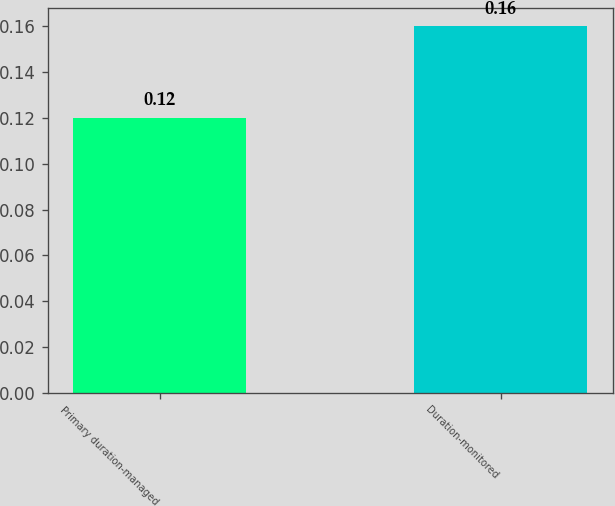Convert chart. <chart><loc_0><loc_0><loc_500><loc_500><bar_chart><fcel>Primary duration-managed<fcel>Duration-monitored<nl><fcel>0.12<fcel>0.16<nl></chart> 